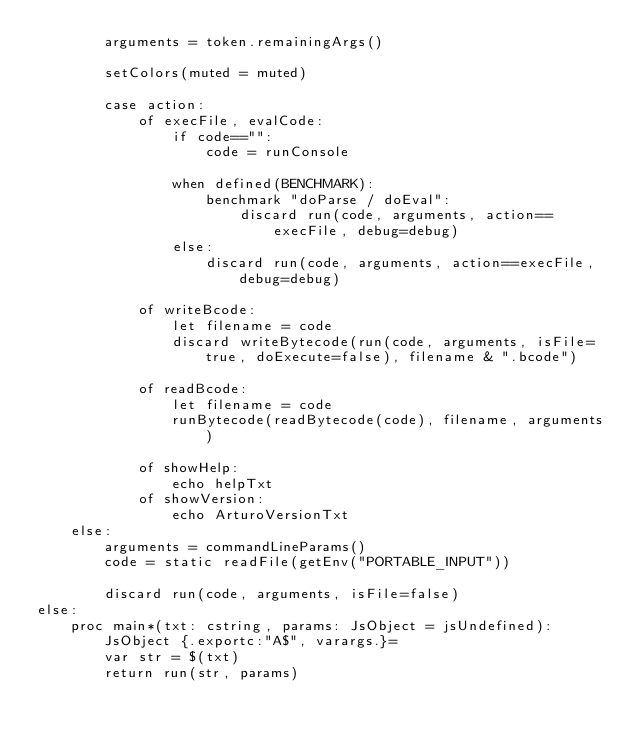Convert code to text. <code><loc_0><loc_0><loc_500><loc_500><_Nim_>        arguments = token.remainingArgs()

        setColors(muted = muted)

        case action:
            of execFile, evalCode:
                if code=="":
                    code = runConsole

                when defined(BENCHMARK):
                    benchmark "doParse / doEval":
                        discard run(code, arguments, action==execFile, debug=debug)
                else:
                    discard run(code, arguments, action==execFile, debug=debug)
                    
            of writeBcode:
                let filename = code
                discard writeBytecode(run(code, arguments, isFile=true, doExecute=false), filename & ".bcode")

            of readBcode:
                let filename = code
                runBytecode(readBytecode(code), filename, arguments)

            of showHelp:
                echo helpTxt
            of showVersion:
                echo ArturoVersionTxt
    else:
        arguments = commandLineParams()
        code = static readFile(getEnv("PORTABLE_INPUT"))

        discard run(code, arguments, isFile=false)
else:
    proc main*(txt: cstring, params: JsObject = jsUndefined): JsObject {.exportc:"A$", varargs.}=
        var str = $(txt)
        return run(str, params)</code> 